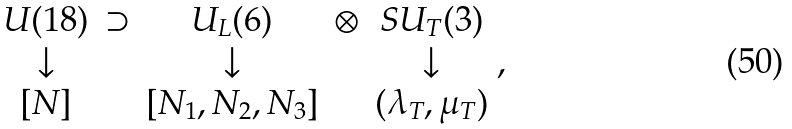<formula> <loc_0><loc_0><loc_500><loc_500>\begin{array} { c c c c c } U ( 1 8 ) & \supset & U _ { L } ( 6 ) & \otimes & S U _ { T } ( 3 ) \\ \downarrow & & \downarrow & & \downarrow \\ { [ N ] } & & [ N _ { 1 } , N _ { 2 } , N _ { 3 } ] & & ( \lambda _ { T } , \mu _ { T } ) \end{array} ,</formula> 